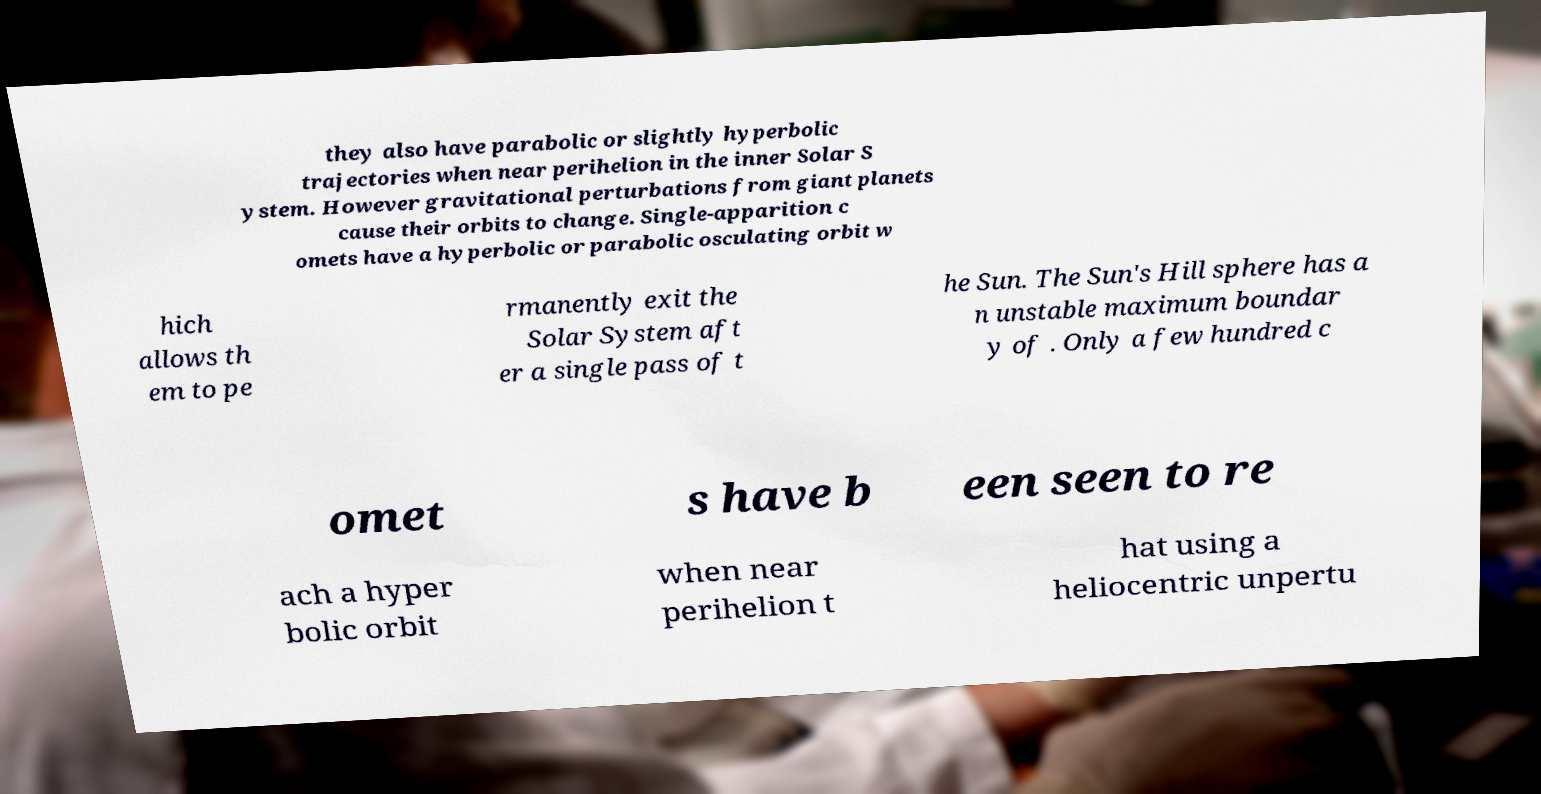I need the written content from this picture converted into text. Can you do that? they also have parabolic or slightly hyperbolic trajectories when near perihelion in the inner Solar S ystem. However gravitational perturbations from giant planets cause their orbits to change. Single-apparition c omets have a hyperbolic or parabolic osculating orbit w hich allows th em to pe rmanently exit the Solar System aft er a single pass of t he Sun. The Sun's Hill sphere has a n unstable maximum boundar y of . Only a few hundred c omet s have b een seen to re ach a hyper bolic orbit when near perihelion t hat using a heliocentric unpertu 